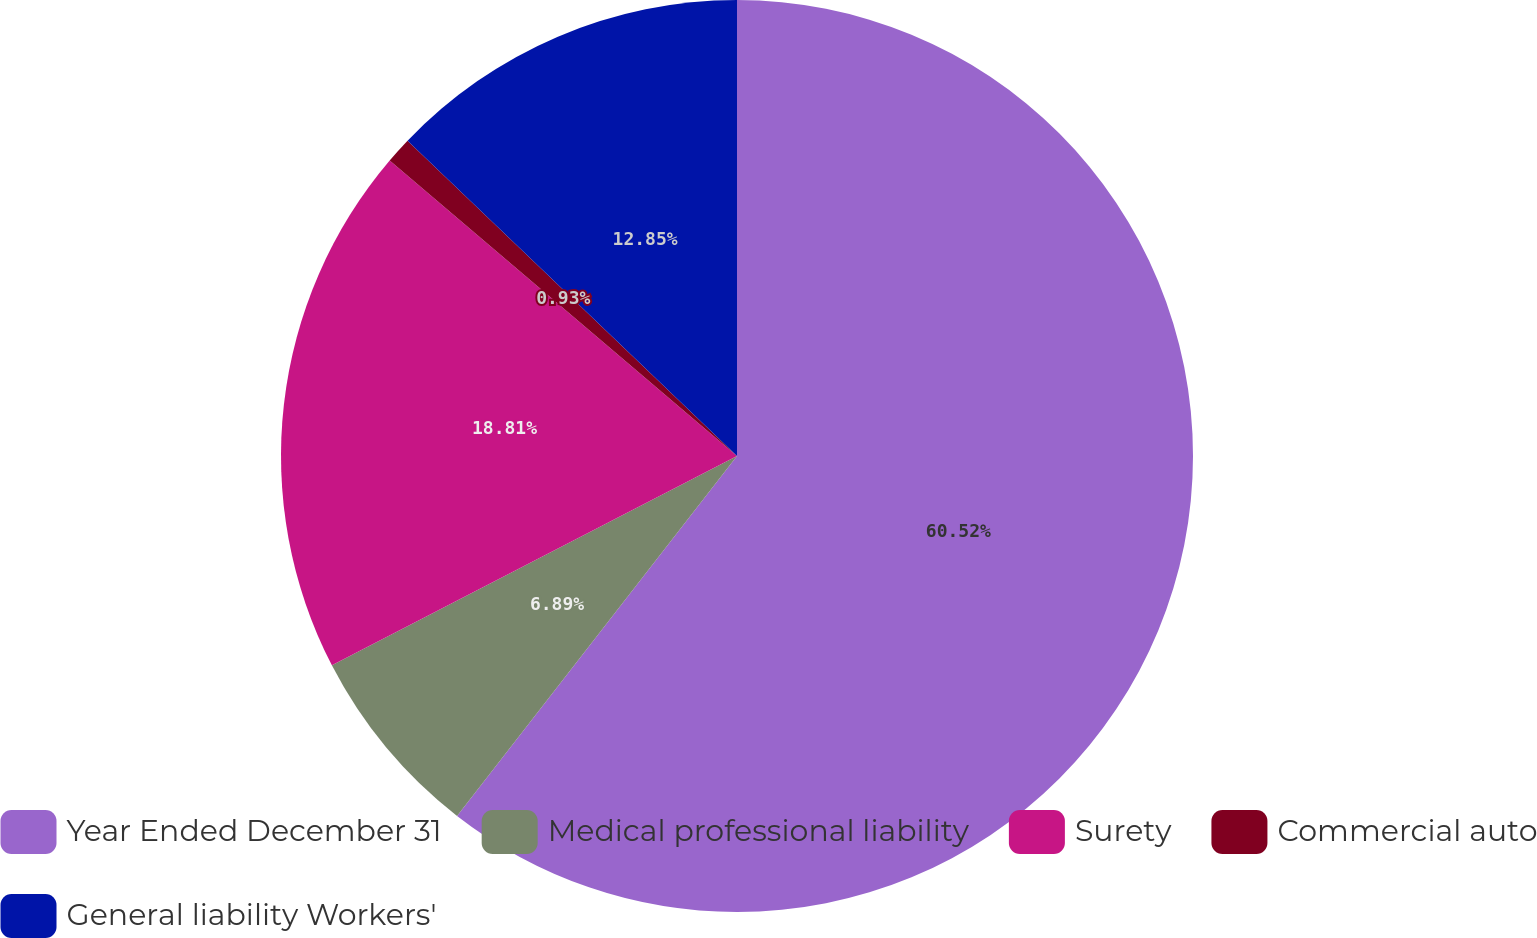<chart> <loc_0><loc_0><loc_500><loc_500><pie_chart><fcel>Year Ended December 31<fcel>Medical professional liability<fcel>Surety<fcel>Commercial auto<fcel>General liability Workers'<nl><fcel>60.52%<fcel>6.89%<fcel>18.81%<fcel>0.93%<fcel>12.85%<nl></chart> 